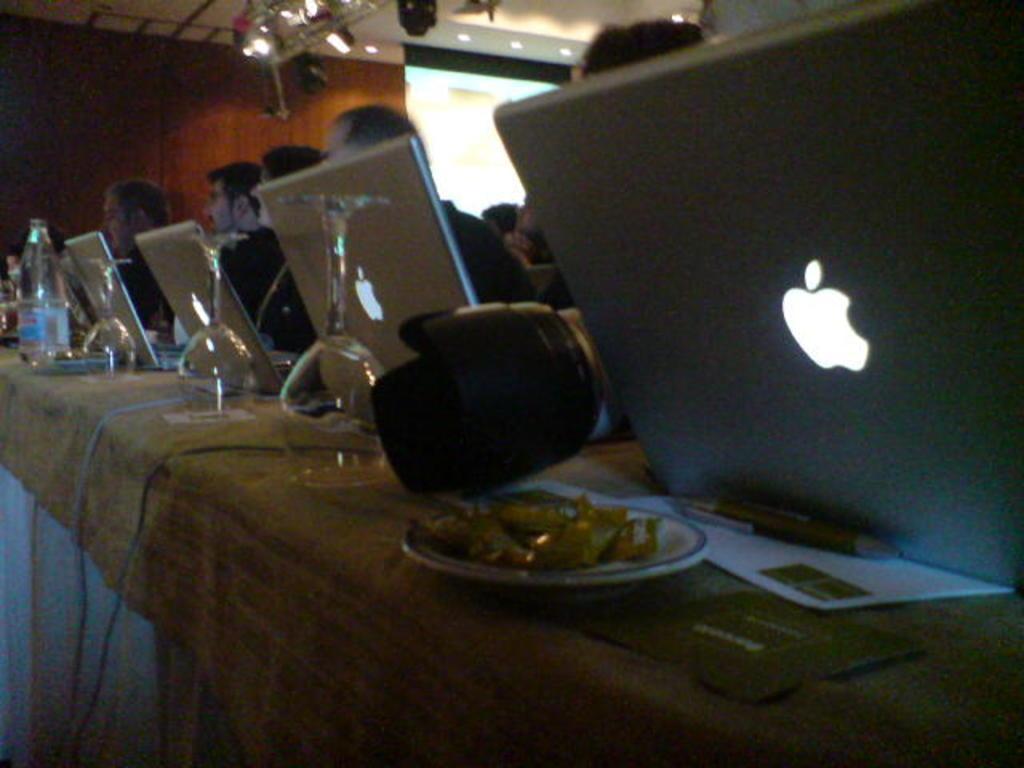Describe this image in one or two sentences. they are so many laptops in a room operated by a people sitting behind and there are some glass with some food in a plate on the table. 